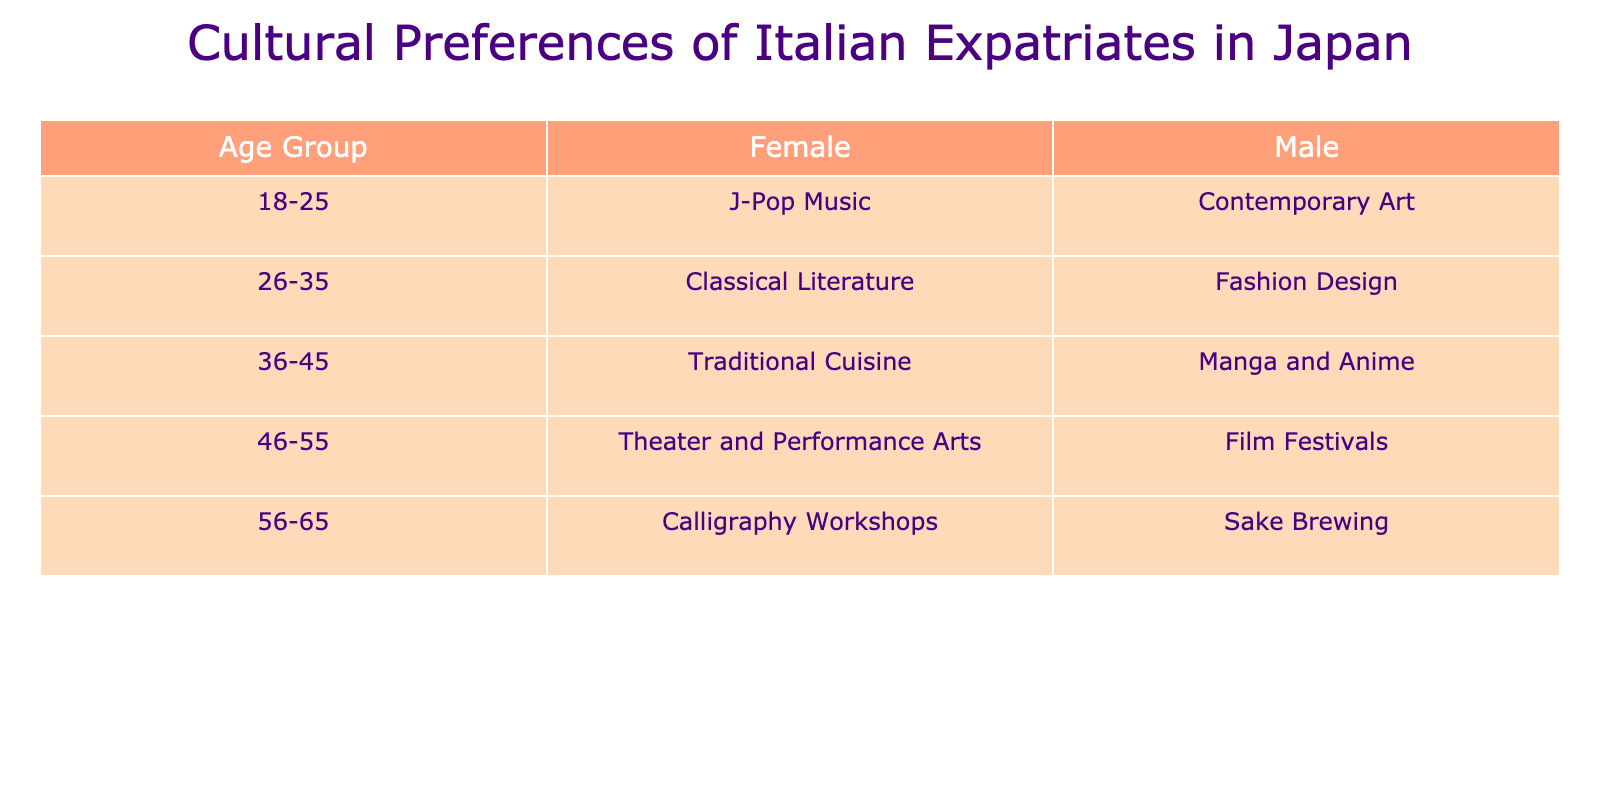What cultural preference do 46-55-year-old females have? The table shows that the cultural preference for 46-55-year-old females is "Theater and Performance Arts." We can find this information by locating the row for the age group 46-55 and then looking under the Female column.
Answer: Theater and Performance Arts How many males prefer Manga and Anime? According to the table, the only male in the age group 36-45 prefers "Manga and Anime." Thus, there is one male who has chosen this preference.
Answer: 1 Do females in the age group 18-25 prefer Contemporary Art? The table indicates that females in the age group 18-25 do not prefer "Contemporary Art"; instead, the preference listed for them is "J-Pop Music." We confirm this by checking the relevant row and column in the table.
Answer: No Which age group has the highest preference for Traditional Cuisine? Only females in the age group 36-45 express a preference for "Traditional Cuisine," and there are no other mentions of this preference for different age groups or genders. Thus, 36-45 is the only age group associated with this preference.
Answer: 36-45 What is the difference in cultural preferences between males and females in the 26-35 age group? The cultural preferences for males and females in the 26-35 age group are "Fashion Design" and "Classical Literature," respectively. There is a single preference for each gender in this age group, resulting in a direct comparison, but this question does not quantify any specific difference or numerical value.
Answer: No numerical difference What cultural interests do older individuals (56-65 age group) favor compared to younger ones (18-25 age group)? For the 56-65 age group, the male preference is "Sake Brewing" and the female preference is "Calligraphy Workshops." In contrast, for the 18-25 age group, males prefer "Contemporary Art" and females prefer "J-Pop Music." This indicates a shift from contemporary interests to traditional and regional interests with age.
Answer: Shift to traditional interests Is there a trend in cultural preferences towards traditional art forms as age increases? The data shows that younger groups favor contemporary forms (like "Contemporary Art" for 18-25 and "Fashion Design" for 26-35) whereas older groups (such as 56-65) favor traditional art forms (like "Sake Brewing" and "Calligraphy Workshops"). This suggests a trend where cultural preferences lean more towards traditional art forms as age increases.
Answer: Yes Which cultural preference is most common among Italian expatriates aged 36-45? Among the individuals aged 36-45, the male preference is "Manga and Anime" and the female preference is "Traditional Cuisine." There are only two preferences listed for this age group, with no repetition, making both equally common within their respective genders.
Answer: No most common preference What preferences do females show compared to males in the 46-55 age group? In the 46-55 age group, females prefer "Theater and Performance Arts," while males prefer "Film Festivals." Since there is only one cultural preference per gender in this age group, we can confirm that they have different preferences without overlap.
Answer: Different preferences 